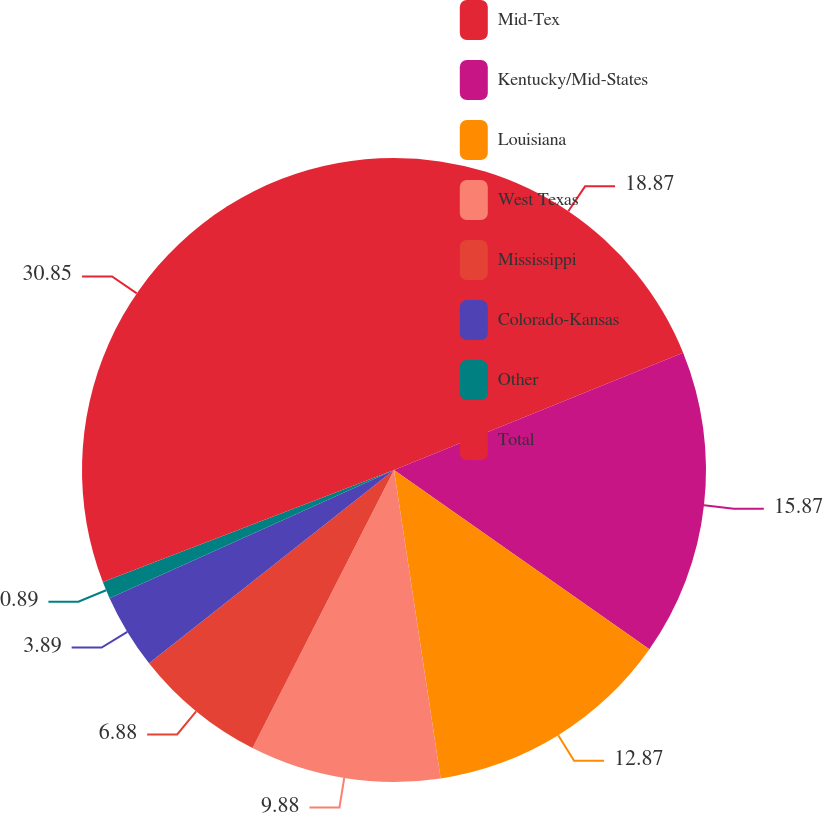<chart> <loc_0><loc_0><loc_500><loc_500><pie_chart><fcel>Mid-Tex<fcel>Kentucky/Mid-States<fcel>Louisiana<fcel>West Texas<fcel>Mississippi<fcel>Colorado-Kansas<fcel>Other<fcel>Total<nl><fcel>18.87%<fcel>15.87%<fcel>12.87%<fcel>9.88%<fcel>6.88%<fcel>3.89%<fcel>0.89%<fcel>30.85%<nl></chart> 